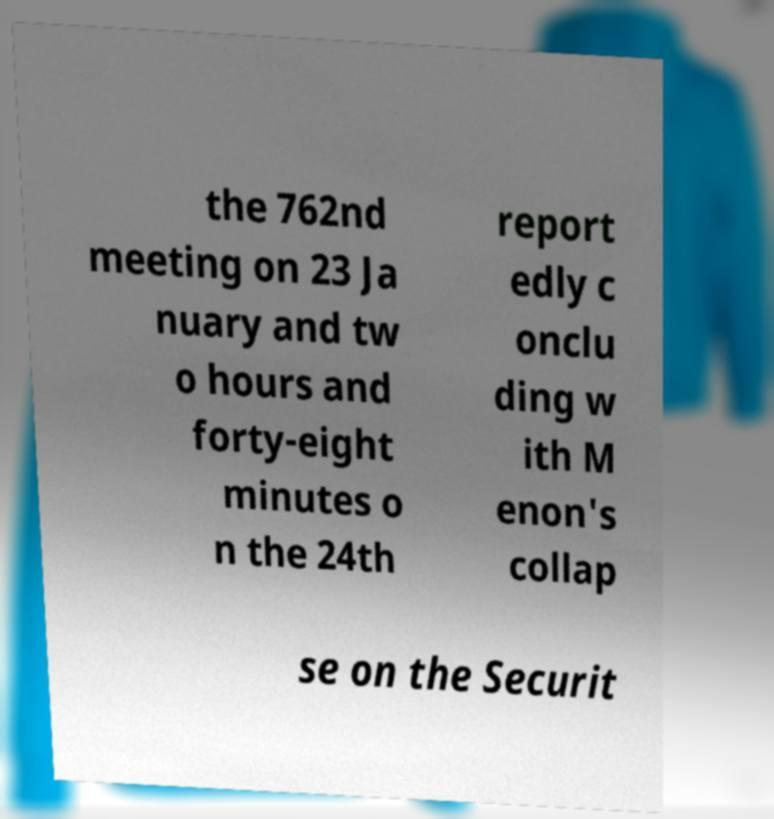Could you assist in decoding the text presented in this image and type it out clearly? the 762nd meeting on 23 Ja nuary and tw o hours and forty-eight minutes o n the 24th report edly c onclu ding w ith M enon's collap se on the Securit 